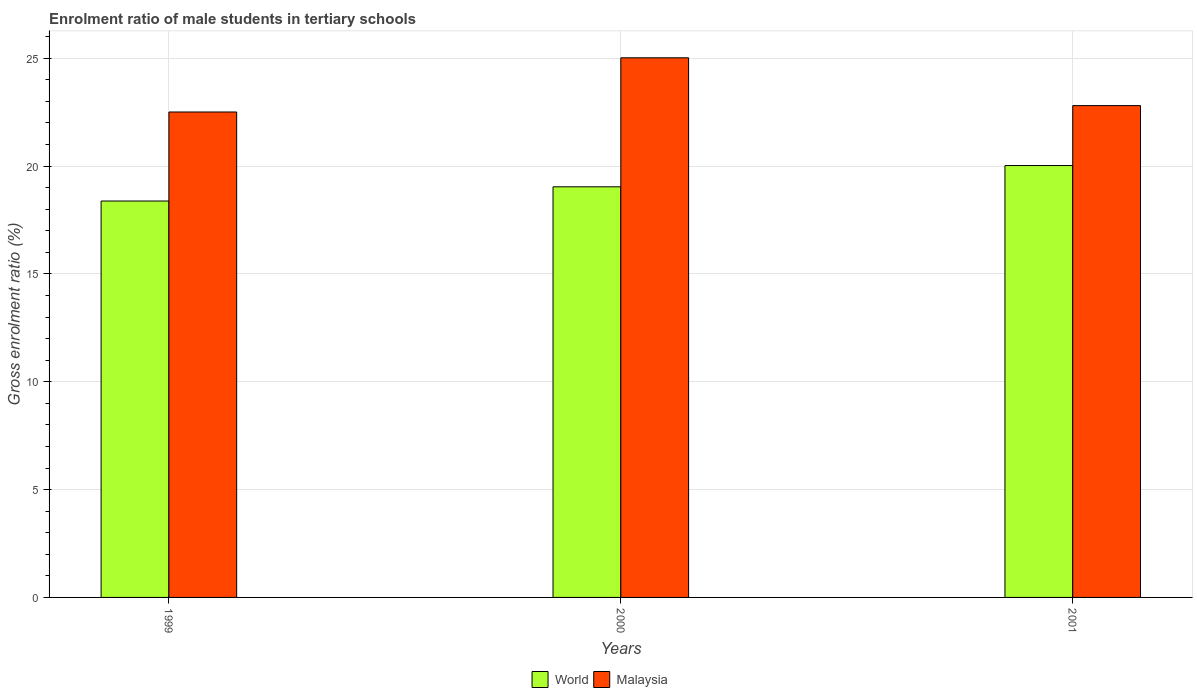How many different coloured bars are there?
Your response must be concise. 2. Are the number of bars per tick equal to the number of legend labels?
Keep it short and to the point. Yes. Are the number of bars on each tick of the X-axis equal?
Offer a very short reply. Yes. What is the label of the 2nd group of bars from the left?
Make the answer very short. 2000. In how many cases, is the number of bars for a given year not equal to the number of legend labels?
Provide a short and direct response. 0. What is the enrolment ratio of male students in tertiary schools in Malaysia in 1999?
Offer a terse response. 22.51. Across all years, what is the maximum enrolment ratio of male students in tertiary schools in Malaysia?
Your response must be concise. 25.02. Across all years, what is the minimum enrolment ratio of male students in tertiary schools in World?
Ensure brevity in your answer.  18.38. In which year was the enrolment ratio of male students in tertiary schools in World minimum?
Provide a succinct answer. 1999. What is the total enrolment ratio of male students in tertiary schools in World in the graph?
Make the answer very short. 57.45. What is the difference between the enrolment ratio of male students in tertiary schools in World in 1999 and that in 2000?
Provide a short and direct response. -0.66. What is the difference between the enrolment ratio of male students in tertiary schools in World in 2000 and the enrolment ratio of male students in tertiary schools in Malaysia in 1999?
Keep it short and to the point. -3.47. What is the average enrolment ratio of male students in tertiary schools in Malaysia per year?
Offer a terse response. 23.45. In the year 2001, what is the difference between the enrolment ratio of male students in tertiary schools in World and enrolment ratio of male students in tertiary schools in Malaysia?
Offer a very short reply. -2.78. In how many years, is the enrolment ratio of male students in tertiary schools in Malaysia greater than 6 %?
Provide a succinct answer. 3. What is the ratio of the enrolment ratio of male students in tertiary schools in Malaysia in 1999 to that in 2001?
Provide a succinct answer. 0.99. Is the enrolment ratio of male students in tertiary schools in Malaysia in 1999 less than that in 2001?
Provide a short and direct response. Yes. What is the difference between the highest and the second highest enrolment ratio of male students in tertiary schools in Malaysia?
Your answer should be compact. 2.22. What is the difference between the highest and the lowest enrolment ratio of male students in tertiary schools in World?
Ensure brevity in your answer.  1.65. Is the sum of the enrolment ratio of male students in tertiary schools in World in 2000 and 2001 greater than the maximum enrolment ratio of male students in tertiary schools in Malaysia across all years?
Your response must be concise. Yes. What does the 2nd bar from the left in 2000 represents?
Make the answer very short. Malaysia. What does the 1st bar from the right in 2001 represents?
Keep it short and to the point. Malaysia. How many years are there in the graph?
Your answer should be very brief. 3. Where does the legend appear in the graph?
Keep it short and to the point. Bottom center. What is the title of the graph?
Offer a very short reply. Enrolment ratio of male students in tertiary schools. Does "Sao Tome and Principe" appear as one of the legend labels in the graph?
Make the answer very short. No. What is the label or title of the X-axis?
Ensure brevity in your answer.  Years. What is the Gross enrolment ratio (%) of World in 1999?
Ensure brevity in your answer.  18.38. What is the Gross enrolment ratio (%) in Malaysia in 1999?
Provide a succinct answer. 22.51. What is the Gross enrolment ratio (%) of World in 2000?
Provide a short and direct response. 19.04. What is the Gross enrolment ratio (%) in Malaysia in 2000?
Provide a succinct answer. 25.02. What is the Gross enrolment ratio (%) in World in 2001?
Provide a succinct answer. 20.03. What is the Gross enrolment ratio (%) of Malaysia in 2001?
Your answer should be very brief. 22.81. Across all years, what is the maximum Gross enrolment ratio (%) of World?
Provide a short and direct response. 20.03. Across all years, what is the maximum Gross enrolment ratio (%) of Malaysia?
Your answer should be very brief. 25.02. Across all years, what is the minimum Gross enrolment ratio (%) in World?
Your answer should be very brief. 18.38. Across all years, what is the minimum Gross enrolment ratio (%) of Malaysia?
Offer a terse response. 22.51. What is the total Gross enrolment ratio (%) of World in the graph?
Your answer should be very brief. 57.45. What is the total Gross enrolment ratio (%) in Malaysia in the graph?
Ensure brevity in your answer.  70.34. What is the difference between the Gross enrolment ratio (%) in World in 1999 and that in 2000?
Provide a succinct answer. -0.66. What is the difference between the Gross enrolment ratio (%) of Malaysia in 1999 and that in 2000?
Your answer should be very brief. -2.51. What is the difference between the Gross enrolment ratio (%) of World in 1999 and that in 2001?
Provide a succinct answer. -1.65. What is the difference between the Gross enrolment ratio (%) in Malaysia in 1999 and that in 2001?
Offer a very short reply. -0.3. What is the difference between the Gross enrolment ratio (%) of World in 2000 and that in 2001?
Ensure brevity in your answer.  -0.99. What is the difference between the Gross enrolment ratio (%) in Malaysia in 2000 and that in 2001?
Provide a short and direct response. 2.22. What is the difference between the Gross enrolment ratio (%) in World in 1999 and the Gross enrolment ratio (%) in Malaysia in 2000?
Offer a terse response. -6.64. What is the difference between the Gross enrolment ratio (%) in World in 1999 and the Gross enrolment ratio (%) in Malaysia in 2001?
Your answer should be very brief. -4.42. What is the difference between the Gross enrolment ratio (%) in World in 2000 and the Gross enrolment ratio (%) in Malaysia in 2001?
Give a very brief answer. -3.76. What is the average Gross enrolment ratio (%) of World per year?
Keep it short and to the point. 19.15. What is the average Gross enrolment ratio (%) in Malaysia per year?
Provide a short and direct response. 23.45. In the year 1999, what is the difference between the Gross enrolment ratio (%) of World and Gross enrolment ratio (%) of Malaysia?
Offer a very short reply. -4.13. In the year 2000, what is the difference between the Gross enrolment ratio (%) of World and Gross enrolment ratio (%) of Malaysia?
Ensure brevity in your answer.  -5.98. In the year 2001, what is the difference between the Gross enrolment ratio (%) of World and Gross enrolment ratio (%) of Malaysia?
Your answer should be compact. -2.78. What is the ratio of the Gross enrolment ratio (%) of World in 1999 to that in 2000?
Provide a short and direct response. 0.97. What is the ratio of the Gross enrolment ratio (%) in Malaysia in 1999 to that in 2000?
Offer a terse response. 0.9. What is the ratio of the Gross enrolment ratio (%) of World in 1999 to that in 2001?
Your answer should be compact. 0.92. What is the ratio of the Gross enrolment ratio (%) of World in 2000 to that in 2001?
Make the answer very short. 0.95. What is the ratio of the Gross enrolment ratio (%) in Malaysia in 2000 to that in 2001?
Keep it short and to the point. 1.1. What is the difference between the highest and the second highest Gross enrolment ratio (%) of World?
Your answer should be compact. 0.99. What is the difference between the highest and the second highest Gross enrolment ratio (%) in Malaysia?
Provide a succinct answer. 2.22. What is the difference between the highest and the lowest Gross enrolment ratio (%) of World?
Provide a succinct answer. 1.65. What is the difference between the highest and the lowest Gross enrolment ratio (%) in Malaysia?
Make the answer very short. 2.51. 